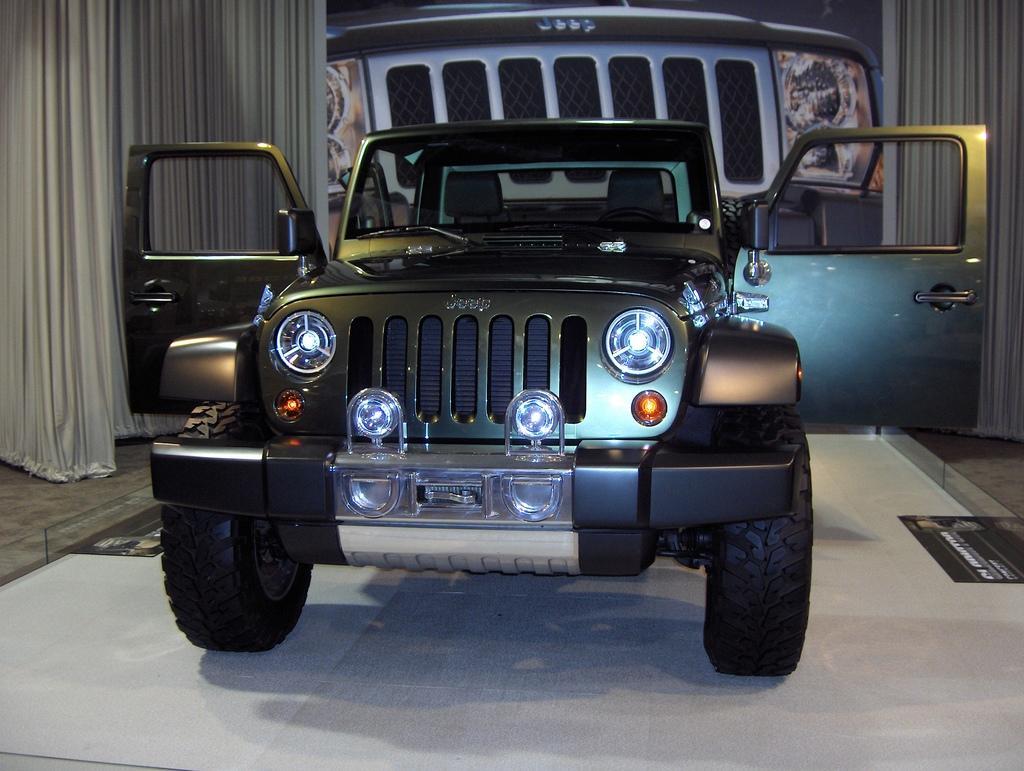In one or two sentences, can you explain what this image depicts? In this picture I can see there is a car and it has wind shield, doors, mirror, head lights and there is a banner of the car in the backdrop and there is a curtain. 